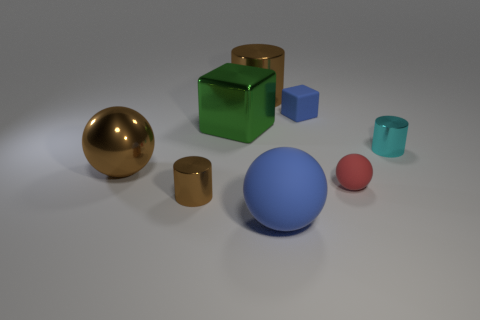Does the big thing that is in front of the metallic ball have the same color as the matte object that is behind the green block?
Give a very brief answer. Yes. There is a thing that is the same color as the rubber cube; what is its size?
Your answer should be very brief. Large. Is there a blue object made of the same material as the red ball?
Provide a short and direct response. Yes. The big rubber sphere has what color?
Your response must be concise. Blue. What size is the matte sphere behind the metallic thing in front of the tiny red ball that is in front of the tiny blue rubber object?
Offer a terse response. Small. What number of other things are there of the same shape as the cyan thing?
Provide a succinct answer. 2. The small thing that is both in front of the cyan cylinder and to the right of the tiny blue thing is what color?
Keep it short and to the point. Red. There is a tiny cylinder to the left of the blue ball; is it the same color as the big shiny sphere?
Your response must be concise. Yes. What number of cubes are either metal things or green metal objects?
Make the answer very short. 1. What is the shape of the large brown object that is on the right side of the big brown metallic ball?
Give a very brief answer. Cylinder. 